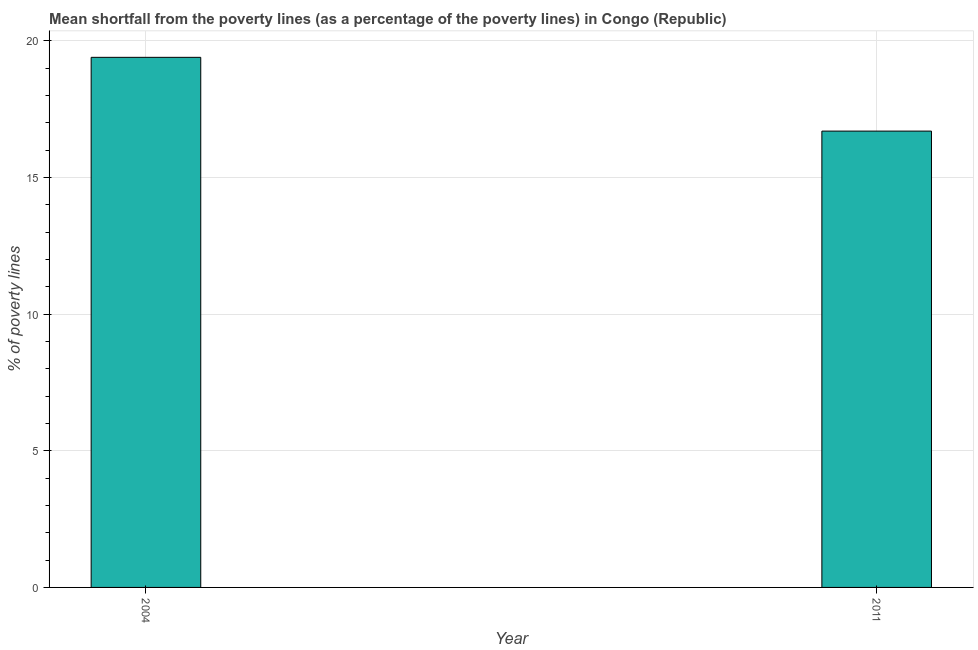What is the title of the graph?
Provide a short and direct response. Mean shortfall from the poverty lines (as a percentage of the poverty lines) in Congo (Republic). What is the label or title of the X-axis?
Your answer should be very brief. Year. What is the label or title of the Y-axis?
Your answer should be very brief. % of poverty lines. Across all years, what is the maximum poverty gap at national poverty lines?
Your answer should be compact. 19.4. What is the sum of the poverty gap at national poverty lines?
Offer a very short reply. 36.1. What is the average poverty gap at national poverty lines per year?
Provide a succinct answer. 18.05. What is the median poverty gap at national poverty lines?
Keep it short and to the point. 18.05. What is the ratio of the poverty gap at national poverty lines in 2004 to that in 2011?
Your answer should be very brief. 1.16. How many bars are there?
Your answer should be very brief. 2. How many years are there in the graph?
Offer a terse response. 2. Are the values on the major ticks of Y-axis written in scientific E-notation?
Provide a succinct answer. No. What is the % of poverty lines in 2011?
Make the answer very short. 16.7. What is the ratio of the % of poverty lines in 2004 to that in 2011?
Keep it short and to the point. 1.16. 